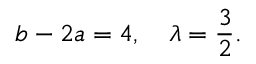Convert formula to latex. <formula><loc_0><loc_0><loc_500><loc_500>b - 2 a = 4 , \quad \lambda = \frac { 3 } { 2 } .</formula> 